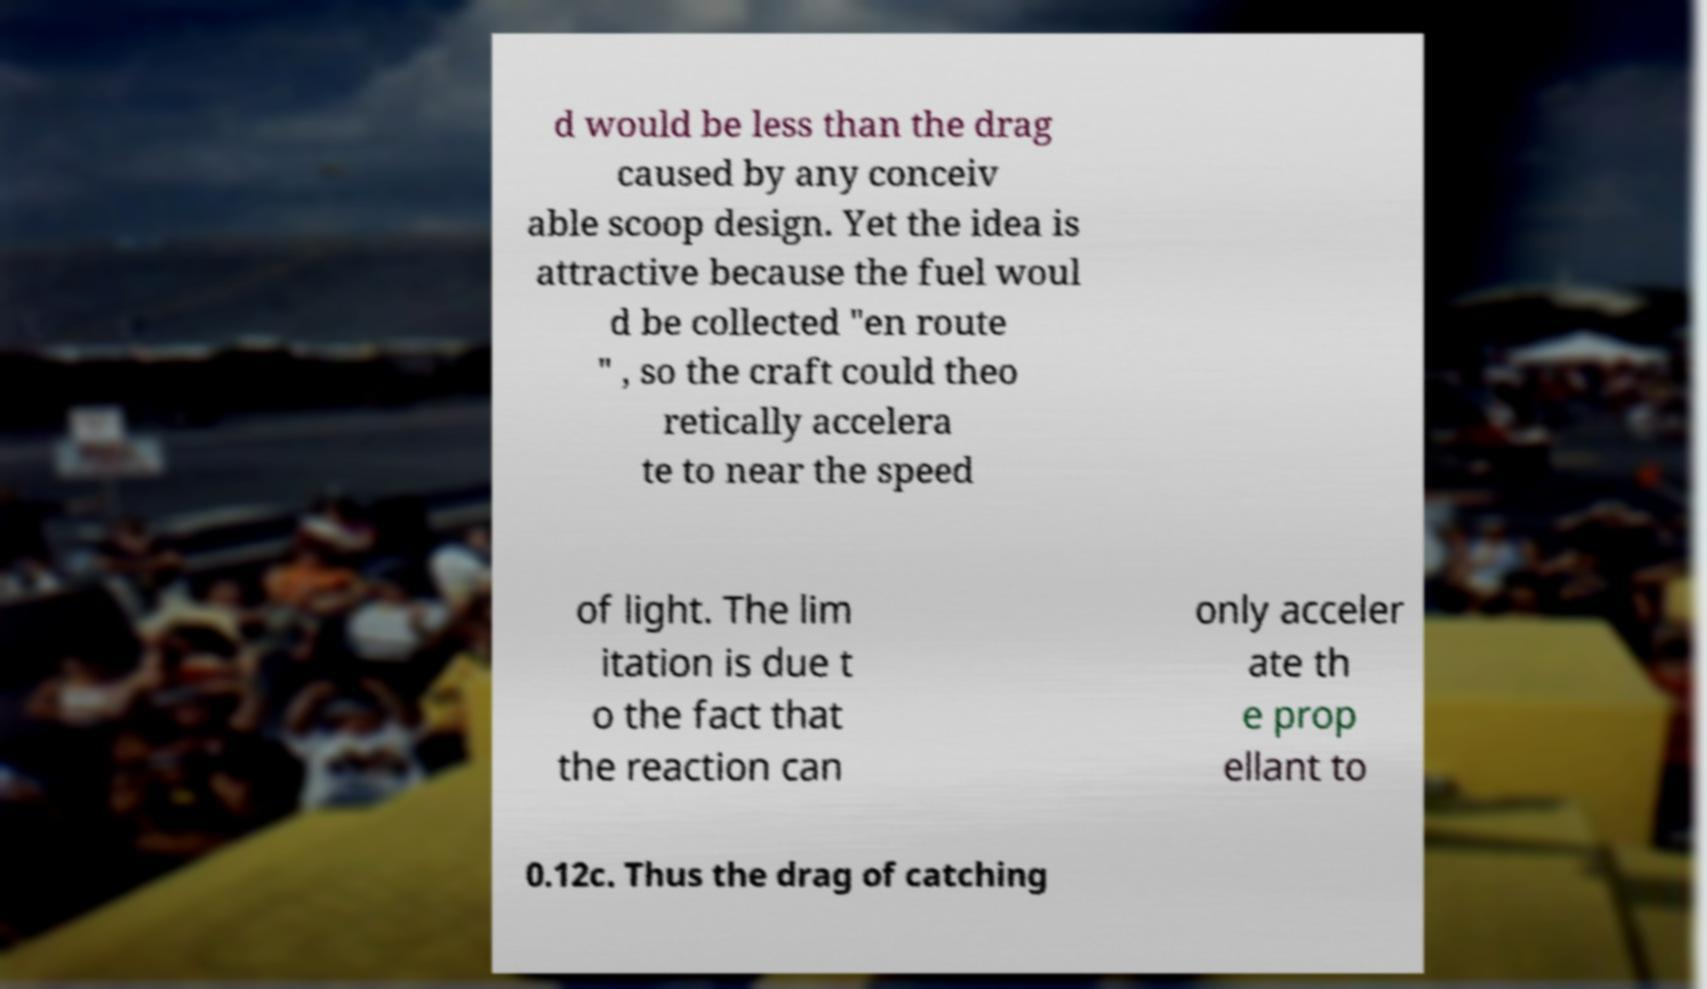Can you accurately transcribe the text from the provided image for me? d would be less than the drag caused by any conceiv able scoop design. Yet the idea is attractive because the fuel woul d be collected "en route " , so the craft could theo retically accelera te to near the speed of light. The lim itation is due t o the fact that the reaction can only acceler ate th e prop ellant to 0.12c. Thus the drag of catching 